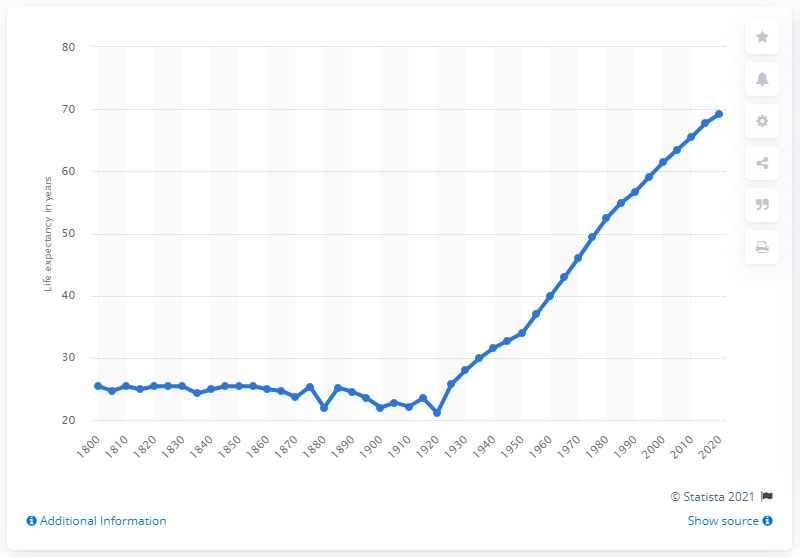List a handful of essential elements in this visual. In the year 1920, India's life expectancy increased. 